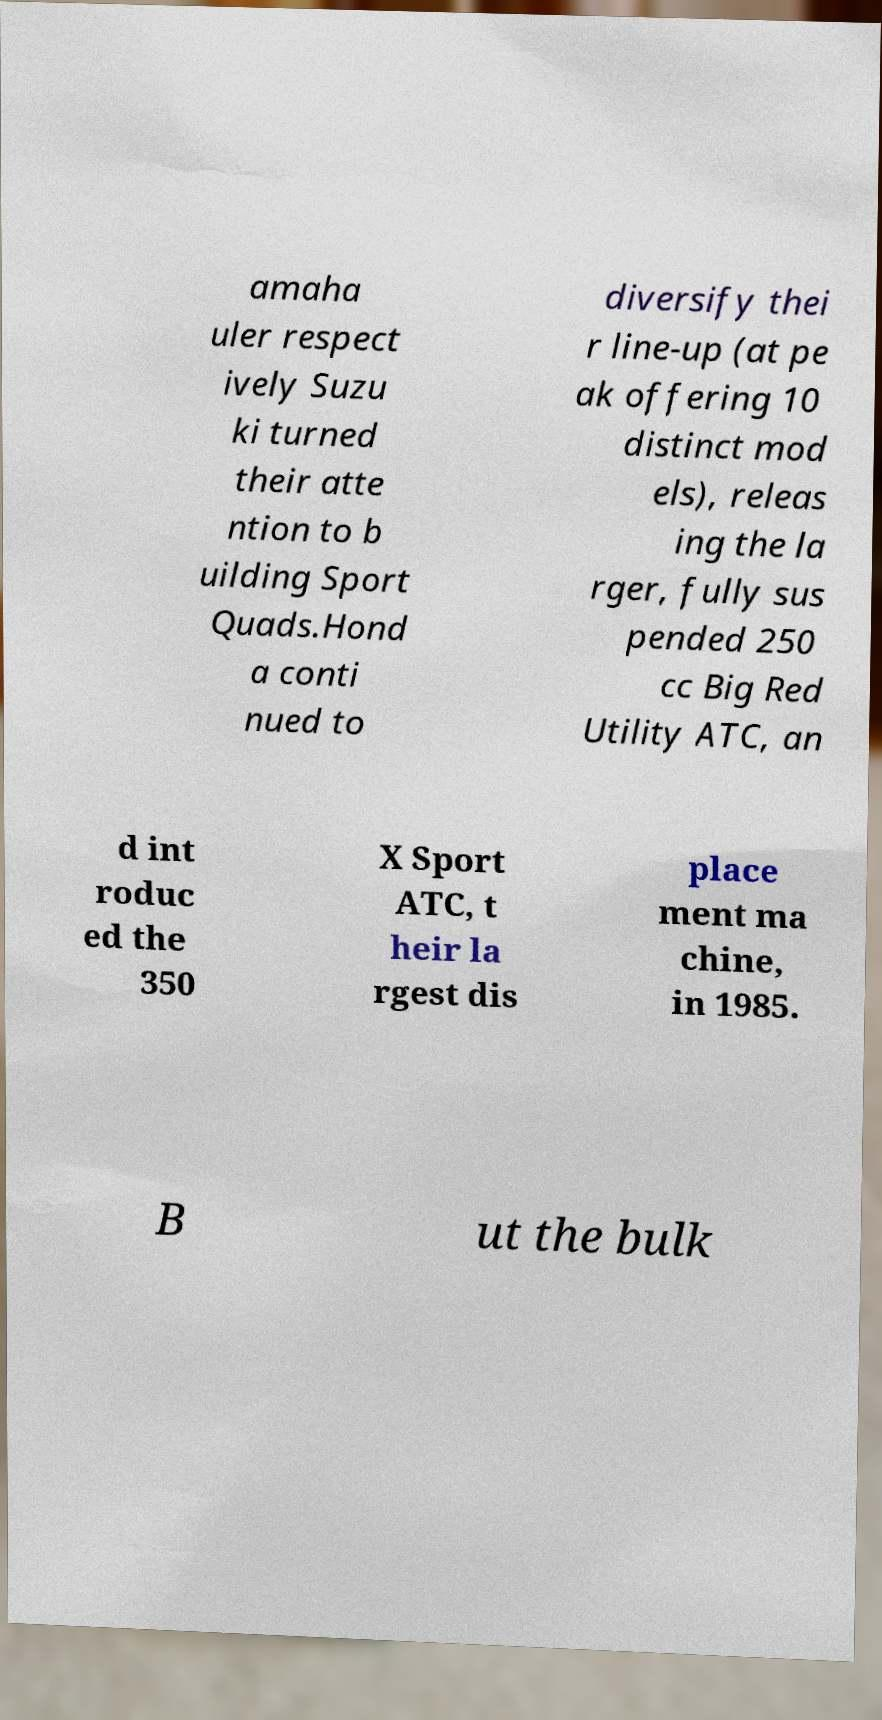For documentation purposes, I need the text within this image transcribed. Could you provide that? amaha uler respect ively Suzu ki turned their atte ntion to b uilding Sport Quads.Hond a conti nued to diversify thei r line-up (at pe ak offering 10 distinct mod els), releas ing the la rger, fully sus pended 250 cc Big Red Utility ATC, an d int roduc ed the 350 X Sport ATC, t heir la rgest dis place ment ma chine, in 1985. B ut the bulk 